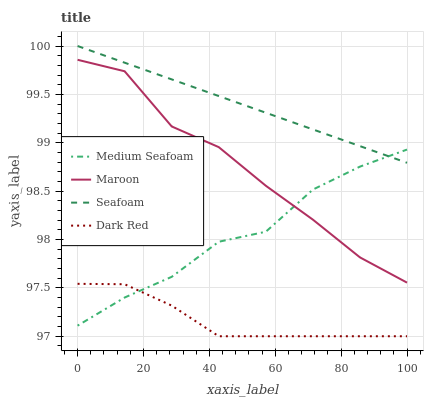Does Dark Red have the minimum area under the curve?
Answer yes or no. Yes. Does Seafoam have the maximum area under the curve?
Answer yes or no. Yes. Does Medium Seafoam have the minimum area under the curve?
Answer yes or no. No. Does Medium Seafoam have the maximum area under the curve?
Answer yes or no. No. Is Seafoam the smoothest?
Answer yes or no. Yes. Is Maroon the roughest?
Answer yes or no. Yes. Is Medium Seafoam the smoothest?
Answer yes or no. No. Is Medium Seafoam the roughest?
Answer yes or no. No. Does Medium Seafoam have the lowest value?
Answer yes or no. No. Does Medium Seafoam have the highest value?
Answer yes or no. No. Is Dark Red less than Maroon?
Answer yes or no. Yes. Is Maroon greater than Dark Red?
Answer yes or no. Yes. Does Dark Red intersect Maroon?
Answer yes or no. No. 